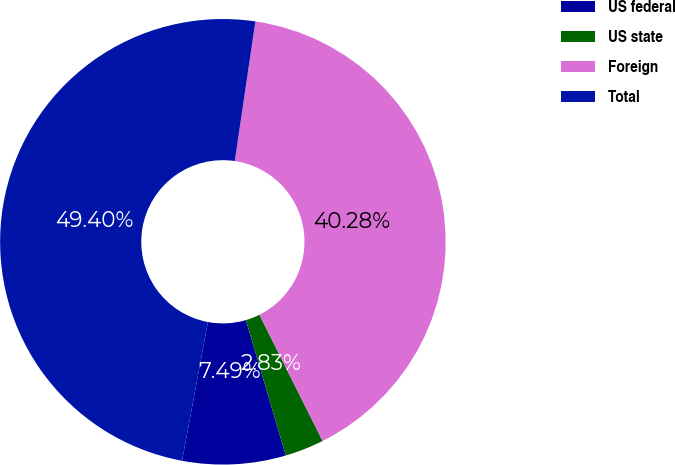Convert chart. <chart><loc_0><loc_0><loc_500><loc_500><pie_chart><fcel>US federal<fcel>US state<fcel>Foreign<fcel>Total<nl><fcel>7.49%<fcel>2.83%<fcel>40.28%<fcel>49.4%<nl></chart> 